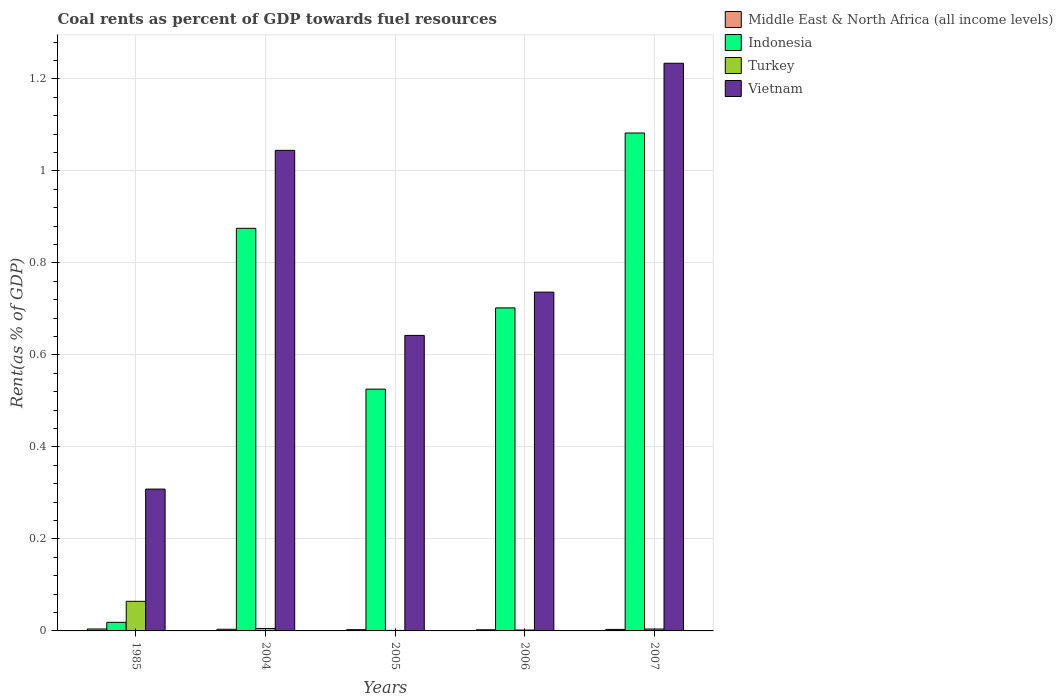How many groups of bars are there?
Keep it short and to the point. 5. Are the number of bars per tick equal to the number of legend labels?
Make the answer very short. Yes. What is the label of the 4th group of bars from the left?
Offer a very short reply. 2006. What is the coal rent in Indonesia in 2004?
Provide a succinct answer. 0.88. Across all years, what is the maximum coal rent in Vietnam?
Ensure brevity in your answer.  1.23. Across all years, what is the minimum coal rent in Middle East & North Africa (all income levels)?
Your answer should be very brief. 0. What is the total coal rent in Turkey in the graph?
Provide a succinct answer. 0.08. What is the difference between the coal rent in Indonesia in 2004 and that in 2006?
Offer a very short reply. 0.17. What is the difference between the coal rent in Vietnam in 2007 and the coal rent in Indonesia in 2004?
Your response must be concise. 0.36. What is the average coal rent in Vietnam per year?
Keep it short and to the point. 0.79. In the year 2006, what is the difference between the coal rent in Indonesia and coal rent in Turkey?
Ensure brevity in your answer.  0.7. In how many years, is the coal rent in Indonesia greater than 0.48000000000000004 %?
Make the answer very short. 4. What is the ratio of the coal rent in Middle East & North Africa (all income levels) in 1985 to that in 2007?
Ensure brevity in your answer.  1.29. Is the coal rent in Middle East & North Africa (all income levels) in 2006 less than that in 2007?
Make the answer very short. Yes. What is the difference between the highest and the second highest coal rent in Turkey?
Make the answer very short. 0.06. What is the difference between the highest and the lowest coal rent in Indonesia?
Offer a very short reply. 1.06. Is it the case that in every year, the sum of the coal rent in Middle East & North Africa (all income levels) and coal rent in Vietnam is greater than the sum of coal rent in Indonesia and coal rent in Turkey?
Give a very brief answer. Yes. What does the 4th bar from the left in 2004 represents?
Keep it short and to the point. Vietnam. What does the 1st bar from the right in 2007 represents?
Offer a terse response. Vietnam. Is it the case that in every year, the sum of the coal rent in Vietnam and coal rent in Turkey is greater than the coal rent in Indonesia?
Offer a terse response. Yes. What is the difference between two consecutive major ticks on the Y-axis?
Offer a very short reply. 0.2. Are the values on the major ticks of Y-axis written in scientific E-notation?
Offer a terse response. No. Where does the legend appear in the graph?
Ensure brevity in your answer.  Top right. How many legend labels are there?
Offer a very short reply. 4. How are the legend labels stacked?
Provide a short and direct response. Vertical. What is the title of the graph?
Provide a succinct answer. Coal rents as percent of GDP towards fuel resources. What is the label or title of the Y-axis?
Offer a very short reply. Rent(as % of GDP). What is the Rent(as % of GDP) of Middle East & North Africa (all income levels) in 1985?
Your answer should be very brief. 0. What is the Rent(as % of GDP) in Indonesia in 1985?
Make the answer very short. 0.02. What is the Rent(as % of GDP) of Turkey in 1985?
Offer a very short reply. 0.06. What is the Rent(as % of GDP) in Vietnam in 1985?
Keep it short and to the point. 0.31. What is the Rent(as % of GDP) in Middle East & North Africa (all income levels) in 2004?
Your response must be concise. 0. What is the Rent(as % of GDP) in Indonesia in 2004?
Your answer should be very brief. 0.88. What is the Rent(as % of GDP) in Turkey in 2004?
Provide a short and direct response. 0.01. What is the Rent(as % of GDP) of Vietnam in 2004?
Your answer should be very brief. 1.04. What is the Rent(as % of GDP) in Middle East & North Africa (all income levels) in 2005?
Provide a succinct answer. 0. What is the Rent(as % of GDP) in Indonesia in 2005?
Your response must be concise. 0.53. What is the Rent(as % of GDP) of Turkey in 2005?
Make the answer very short. 0. What is the Rent(as % of GDP) in Vietnam in 2005?
Give a very brief answer. 0.64. What is the Rent(as % of GDP) in Middle East & North Africa (all income levels) in 2006?
Offer a terse response. 0. What is the Rent(as % of GDP) in Indonesia in 2006?
Keep it short and to the point. 0.7. What is the Rent(as % of GDP) of Turkey in 2006?
Your response must be concise. 0. What is the Rent(as % of GDP) of Vietnam in 2006?
Make the answer very short. 0.74. What is the Rent(as % of GDP) in Middle East & North Africa (all income levels) in 2007?
Provide a succinct answer. 0. What is the Rent(as % of GDP) of Indonesia in 2007?
Your answer should be compact. 1.08. What is the Rent(as % of GDP) of Turkey in 2007?
Provide a succinct answer. 0. What is the Rent(as % of GDP) in Vietnam in 2007?
Keep it short and to the point. 1.23. Across all years, what is the maximum Rent(as % of GDP) in Middle East & North Africa (all income levels)?
Provide a short and direct response. 0. Across all years, what is the maximum Rent(as % of GDP) in Indonesia?
Make the answer very short. 1.08. Across all years, what is the maximum Rent(as % of GDP) of Turkey?
Your answer should be very brief. 0.06. Across all years, what is the maximum Rent(as % of GDP) of Vietnam?
Offer a very short reply. 1.23. Across all years, what is the minimum Rent(as % of GDP) in Middle East & North Africa (all income levels)?
Offer a terse response. 0. Across all years, what is the minimum Rent(as % of GDP) in Indonesia?
Give a very brief answer. 0.02. Across all years, what is the minimum Rent(as % of GDP) in Turkey?
Keep it short and to the point. 0. Across all years, what is the minimum Rent(as % of GDP) in Vietnam?
Your answer should be compact. 0.31. What is the total Rent(as % of GDP) of Middle East & North Africa (all income levels) in the graph?
Give a very brief answer. 0.02. What is the total Rent(as % of GDP) in Indonesia in the graph?
Keep it short and to the point. 3.2. What is the total Rent(as % of GDP) in Turkey in the graph?
Give a very brief answer. 0.08. What is the total Rent(as % of GDP) in Vietnam in the graph?
Offer a very short reply. 3.97. What is the difference between the Rent(as % of GDP) in Middle East & North Africa (all income levels) in 1985 and that in 2004?
Ensure brevity in your answer.  0. What is the difference between the Rent(as % of GDP) in Indonesia in 1985 and that in 2004?
Make the answer very short. -0.86. What is the difference between the Rent(as % of GDP) of Turkey in 1985 and that in 2004?
Your answer should be compact. 0.06. What is the difference between the Rent(as % of GDP) of Vietnam in 1985 and that in 2004?
Offer a terse response. -0.74. What is the difference between the Rent(as % of GDP) of Middle East & North Africa (all income levels) in 1985 and that in 2005?
Provide a short and direct response. 0. What is the difference between the Rent(as % of GDP) in Indonesia in 1985 and that in 2005?
Offer a terse response. -0.51. What is the difference between the Rent(as % of GDP) in Turkey in 1985 and that in 2005?
Offer a very short reply. 0.06. What is the difference between the Rent(as % of GDP) of Vietnam in 1985 and that in 2005?
Give a very brief answer. -0.33. What is the difference between the Rent(as % of GDP) in Middle East & North Africa (all income levels) in 1985 and that in 2006?
Your answer should be very brief. 0. What is the difference between the Rent(as % of GDP) of Indonesia in 1985 and that in 2006?
Your answer should be very brief. -0.68. What is the difference between the Rent(as % of GDP) in Turkey in 1985 and that in 2006?
Make the answer very short. 0.06. What is the difference between the Rent(as % of GDP) of Vietnam in 1985 and that in 2006?
Ensure brevity in your answer.  -0.43. What is the difference between the Rent(as % of GDP) in Indonesia in 1985 and that in 2007?
Your response must be concise. -1.06. What is the difference between the Rent(as % of GDP) in Turkey in 1985 and that in 2007?
Make the answer very short. 0.06. What is the difference between the Rent(as % of GDP) in Vietnam in 1985 and that in 2007?
Offer a very short reply. -0.93. What is the difference between the Rent(as % of GDP) of Middle East & North Africa (all income levels) in 2004 and that in 2005?
Your answer should be compact. 0. What is the difference between the Rent(as % of GDP) of Indonesia in 2004 and that in 2005?
Keep it short and to the point. 0.35. What is the difference between the Rent(as % of GDP) in Turkey in 2004 and that in 2005?
Provide a short and direct response. 0. What is the difference between the Rent(as % of GDP) of Vietnam in 2004 and that in 2005?
Offer a terse response. 0.4. What is the difference between the Rent(as % of GDP) of Middle East & North Africa (all income levels) in 2004 and that in 2006?
Your answer should be compact. 0. What is the difference between the Rent(as % of GDP) in Indonesia in 2004 and that in 2006?
Provide a succinct answer. 0.17. What is the difference between the Rent(as % of GDP) of Turkey in 2004 and that in 2006?
Your answer should be very brief. 0. What is the difference between the Rent(as % of GDP) of Vietnam in 2004 and that in 2006?
Your response must be concise. 0.31. What is the difference between the Rent(as % of GDP) in Middle East & North Africa (all income levels) in 2004 and that in 2007?
Provide a succinct answer. 0. What is the difference between the Rent(as % of GDP) in Indonesia in 2004 and that in 2007?
Your response must be concise. -0.21. What is the difference between the Rent(as % of GDP) of Turkey in 2004 and that in 2007?
Offer a terse response. 0. What is the difference between the Rent(as % of GDP) in Vietnam in 2004 and that in 2007?
Give a very brief answer. -0.19. What is the difference between the Rent(as % of GDP) in Middle East & North Africa (all income levels) in 2005 and that in 2006?
Provide a succinct answer. 0. What is the difference between the Rent(as % of GDP) in Indonesia in 2005 and that in 2006?
Keep it short and to the point. -0.18. What is the difference between the Rent(as % of GDP) in Turkey in 2005 and that in 2006?
Ensure brevity in your answer.  -0. What is the difference between the Rent(as % of GDP) in Vietnam in 2005 and that in 2006?
Provide a succinct answer. -0.09. What is the difference between the Rent(as % of GDP) in Middle East & North Africa (all income levels) in 2005 and that in 2007?
Keep it short and to the point. -0. What is the difference between the Rent(as % of GDP) in Indonesia in 2005 and that in 2007?
Offer a terse response. -0.56. What is the difference between the Rent(as % of GDP) of Turkey in 2005 and that in 2007?
Your answer should be compact. -0. What is the difference between the Rent(as % of GDP) in Vietnam in 2005 and that in 2007?
Your response must be concise. -0.59. What is the difference between the Rent(as % of GDP) in Middle East & North Africa (all income levels) in 2006 and that in 2007?
Your answer should be very brief. -0. What is the difference between the Rent(as % of GDP) of Indonesia in 2006 and that in 2007?
Provide a succinct answer. -0.38. What is the difference between the Rent(as % of GDP) of Turkey in 2006 and that in 2007?
Your answer should be compact. -0. What is the difference between the Rent(as % of GDP) of Vietnam in 2006 and that in 2007?
Your response must be concise. -0.5. What is the difference between the Rent(as % of GDP) of Middle East & North Africa (all income levels) in 1985 and the Rent(as % of GDP) of Indonesia in 2004?
Your answer should be very brief. -0.87. What is the difference between the Rent(as % of GDP) in Middle East & North Africa (all income levels) in 1985 and the Rent(as % of GDP) in Turkey in 2004?
Ensure brevity in your answer.  -0. What is the difference between the Rent(as % of GDP) of Middle East & North Africa (all income levels) in 1985 and the Rent(as % of GDP) of Vietnam in 2004?
Provide a succinct answer. -1.04. What is the difference between the Rent(as % of GDP) of Indonesia in 1985 and the Rent(as % of GDP) of Turkey in 2004?
Keep it short and to the point. 0.01. What is the difference between the Rent(as % of GDP) of Indonesia in 1985 and the Rent(as % of GDP) of Vietnam in 2004?
Offer a very short reply. -1.03. What is the difference between the Rent(as % of GDP) in Turkey in 1985 and the Rent(as % of GDP) in Vietnam in 2004?
Provide a short and direct response. -0.98. What is the difference between the Rent(as % of GDP) of Middle East & North Africa (all income levels) in 1985 and the Rent(as % of GDP) of Indonesia in 2005?
Offer a terse response. -0.52. What is the difference between the Rent(as % of GDP) of Middle East & North Africa (all income levels) in 1985 and the Rent(as % of GDP) of Turkey in 2005?
Keep it short and to the point. 0. What is the difference between the Rent(as % of GDP) in Middle East & North Africa (all income levels) in 1985 and the Rent(as % of GDP) in Vietnam in 2005?
Provide a succinct answer. -0.64. What is the difference between the Rent(as % of GDP) of Indonesia in 1985 and the Rent(as % of GDP) of Turkey in 2005?
Your answer should be very brief. 0.02. What is the difference between the Rent(as % of GDP) in Indonesia in 1985 and the Rent(as % of GDP) in Vietnam in 2005?
Provide a succinct answer. -0.62. What is the difference between the Rent(as % of GDP) of Turkey in 1985 and the Rent(as % of GDP) of Vietnam in 2005?
Your answer should be very brief. -0.58. What is the difference between the Rent(as % of GDP) of Middle East & North Africa (all income levels) in 1985 and the Rent(as % of GDP) of Indonesia in 2006?
Provide a succinct answer. -0.7. What is the difference between the Rent(as % of GDP) in Middle East & North Africa (all income levels) in 1985 and the Rent(as % of GDP) in Turkey in 2006?
Provide a short and direct response. 0. What is the difference between the Rent(as % of GDP) in Middle East & North Africa (all income levels) in 1985 and the Rent(as % of GDP) in Vietnam in 2006?
Your answer should be compact. -0.73. What is the difference between the Rent(as % of GDP) of Indonesia in 1985 and the Rent(as % of GDP) of Turkey in 2006?
Keep it short and to the point. 0.02. What is the difference between the Rent(as % of GDP) in Indonesia in 1985 and the Rent(as % of GDP) in Vietnam in 2006?
Offer a terse response. -0.72. What is the difference between the Rent(as % of GDP) in Turkey in 1985 and the Rent(as % of GDP) in Vietnam in 2006?
Your answer should be compact. -0.67. What is the difference between the Rent(as % of GDP) in Middle East & North Africa (all income levels) in 1985 and the Rent(as % of GDP) in Indonesia in 2007?
Provide a short and direct response. -1.08. What is the difference between the Rent(as % of GDP) of Middle East & North Africa (all income levels) in 1985 and the Rent(as % of GDP) of Turkey in 2007?
Your response must be concise. 0. What is the difference between the Rent(as % of GDP) of Middle East & North Africa (all income levels) in 1985 and the Rent(as % of GDP) of Vietnam in 2007?
Keep it short and to the point. -1.23. What is the difference between the Rent(as % of GDP) of Indonesia in 1985 and the Rent(as % of GDP) of Turkey in 2007?
Offer a very short reply. 0.01. What is the difference between the Rent(as % of GDP) in Indonesia in 1985 and the Rent(as % of GDP) in Vietnam in 2007?
Offer a terse response. -1.22. What is the difference between the Rent(as % of GDP) in Turkey in 1985 and the Rent(as % of GDP) in Vietnam in 2007?
Offer a very short reply. -1.17. What is the difference between the Rent(as % of GDP) in Middle East & North Africa (all income levels) in 2004 and the Rent(as % of GDP) in Indonesia in 2005?
Ensure brevity in your answer.  -0.52. What is the difference between the Rent(as % of GDP) in Middle East & North Africa (all income levels) in 2004 and the Rent(as % of GDP) in Turkey in 2005?
Your answer should be compact. 0. What is the difference between the Rent(as % of GDP) in Middle East & North Africa (all income levels) in 2004 and the Rent(as % of GDP) in Vietnam in 2005?
Ensure brevity in your answer.  -0.64. What is the difference between the Rent(as % of GDP) in Indonesia in 2004 and the Rent(as % of GDP) in Turkey in 2005?
Make the answer very short. 0.87. What is the difference between the Rent(as % of GDP) of Indonesia in 2004 and the Rent(as % of GDP) of Vietnam in 2005?
Provide a short and direct response. 0.23. What is the difference between the Rent(as % of GDP) of Turkey in 2004 and the Rent(as % of GDP) of Vietnam in 2005?
Make the answer very short. -0.64. What is the difference between the Rent(as % of GDP) of Middle East & North Africa (all income levels) in 2004 and the Rent(as % of GDP) of Indonesia in 2006?
Provide a short and direct response. -0.7. What is the difference between the Rent(as % of GDP) of Middle East & North Africa (all income levels) in 2004 and the Rent(as % of GDP) of Turkey in 2006?
Your response must be concise. 0. What is the difference between the Rent(as % of GDP) of Middle East & North Africa (all income levels) in 2004 and the Rent(as % of GDP) of Vietnam in 2006?
Give a very brief answer. -0.73. What is the difference between the Rent(as % of GDP) in Indonesia in 2004 and the Rent(as % of GDP) in Turkey in 2006?
Provide a short and direct response. 0.87. What is the difference between the Rent(as % of GDP) of Indonesia in 2004 and the Rent(as % of GDP) of Vietnam in 2006?
Give a very brief answer. 0.14. What is the difference between the Rent(as % of GDP) in Turkey in 2004 and the Rent(as % of GDP) in Vietnam in 2006?
Make the answer very short. -0.73. What is the difference between the Rent(as % of GDP) in Middle East & North Africa (all income levels) in 2004 and the Rent(as % of GDP) in Indonesia in 2007?
Provide a succinct answer. -1.08. What is the difference between the Rent(as % of GDP) of Middle East & North Africa (all income levels) in 2004 and the Rent(as % of GDP) of Turkey in 2007?
Provide a short and direct response. -0. What is the difference between the Rent(as % of GDP) in Middle East & North Africa (all income levels) in 2004 and the Rent(as % of GDP) in Vietnam in 2007?
Your answer should be compact. -1.23. What is the difference between the Rent(as % of GDP) of Indonesia in 2004 and the Rent(as % of GDP) of Turkey in 2007?
Your answer should be compact. 0.87. What is the difference between the Rent(as % of GDP) of Indonesia in 2004 and the Rent(as % of GDP) of Vietnam in 2007?
Keep it short and to the point. -0.36. What is the difference between the Rent(as % of GDP) of Turkey in 2004 and the Rent(as % of GDP) of Vietnam in 2007?
Your answer should be very brief. -1.23. What is the difference between the Rent(as % of GDP) in Middle East & North Africa (all income levels) in 2005 and the Rent(as % of GDP) in Indonesia in 2006?
Provide a succinct answer. -0.7. What is the difference between the Rent(as % of GDP) in Middle East & North Africa (all income levels) in 2005 and the Rent(as % of GDP) in Turkey in 2006?
Provide a succinct answer. 0. What is the difference between the Rent(as % of GDP) of Middle East & North Africa (all income levels) in 2005 and the Rent(as % of GDP) of Vietnam in 2006?
Your answer should be compact. -0.73. What is the difference between the Rent(as % of GDP) in Indonesia in 2005 and the Rent(as % of GDP) in Turkey in 2006?
Your response must be concise. 0.52. What is the difference between the Rent(as % of GDP) in Indonesia in 2005 and the Rent(as % of GDP) in Vietnam in 2006?
Make the answer very short. -0.21. What is the difference between the Rent(as % of GDP) in Turkey in 2005 and the Rent(as % of GDP) in Vietnam in 2006?
Offer a terse response. -0.74. What is the difference between the Rent(as % of GDP) in Middle East & North Africa (all income levels) in 2005 and the Rent(as % of GDP) in Indonesia in 2007?
Offer a very short reply. -1.08. What is the difference between the Rent(as % of GDP) of Middle East & North Africa (all income levels) in 2005 and the Rent(as % of GDP) of Turkey in 2007?
Your answer should be very brief. -0. What is the difference between the Rent(as % of GDP) in Middle East & North Africa (all income levels) in 2005 and the Rent(as % of GDP) in Vietnam in 2007?
Your response must be concise. -1.23. What is the difference between the Rent(as % of GDP) in Indonesia in 2005 and the Rent(as % of GDP) in Turkey in 2007?
Keep it short and to the point. 0.52. What is the difference between the Rent(as % of GDP) of Indonesia in 2005 and the Rent(as % of GDP) of Vietnam in 2007?
Provide a succinct answer. -0.71. What is the difference between the Rent(as % of GDP) in Turkey in 2005 and the Rent(as % of GDP) in Vietnam in 2007?
Provide a succinct answer. -1.23. What is the difference between the Rent(as % of GDP) of Middle East & North Africa (all income levels) in 2006 and the Rent(as % of GDP) of Indonesia in 2007?
Give a very brief answer. -1.08. What is the difference between the Rent(as % of GDP) in Middle East & North Africa (all income levels) in 2006 and the Rent(as % of GDP) in Turkey in 2007?
Keep it short and to the point. -0. What is the difference between the Rent(as % of GDP) of Middle East & North Africa (all income levels) in 2006 and the Rent(as % of GDP) of Vietnam in 2007?
Provide a short and direct response. -1.23. What is the difference between the Rent(as % of GDP) in Indonesia in 2006 and the Rent(as % of GDP) in Turkey in 2007?
Give a very brief answer. 0.7. What is the difference between the Rent(as % of GDP) in Indonesia in 2006 and the Rent(as % of GDP) in Vietnam in 2007?
Provide a succinct answer. -0.53. What is the difference between the Rent(as % of GDP) of Turkey in 2006 and the Rent(as % of GDP) of Vietnam in 2007?
Your response must be concise. -1.23. What is the average Rent(as % of GDP) in Middle East & North Africa (all income levels) per year?
Your answer should be very brief. 0. What is the average Rent(as % of GDP) in Indonesia per year?
Provide a succinct answer. 0.64. What is the average Rent(as % of GDP) in Turkey per year?
Provide a short and direct response. 0.02. What is the average Rent(as % of GDP) in Vietnam per year?
Provide a short and direct response. 0.79. In the year 1985, what is the difference between the Rent(as % of GDP) of Middle East & North Africa (all income levels) and Rent(as % of GDP) of Indonesia?
Your response must be concise. -0.01. In the year 1985, what is the difference between the Rent(as % of GDP) of Middle East & North Africa (all income levels) and Rent(as % of GDP) of Turkey?
Provide a short and direct response. -0.06. In the year 1985, what is the difference between the Rent(as % of GDP) in Middle East & North Africa (all income levels) and Rent(as % of GDP) in Vietnam?
Your answer should be very brief. -0.3. In the year 1985, what is the difference between the Rent(as % of GDP) in Indonesia and Rent(as % of GDP) in Turkey?
Provide a succinct answer. -0.05. In the year 1985, what is the difference between the Rent(as % of GDP) in Indonesia and Rent(as % of GDP) in Vietnam?
Ensure brevity in your answer.  -0.29. In the year 1985, what is the difference between the Rent(as % of GDP) in Turkey and Rent(as % of GDP) in Vietnam?
Give a very brief answer. -0.24. In the year 2004, what is the difference between the Rent(as % of GDP) in Middle East & North Africa (all income levels) and Rent(as % of GDP) in Indonesia?
Provide a succinct answer. -0.87. In the year 2004, what is the difference between the Rent(as % of GDP) of Middle East & North Africa (all income levels) and Rent(as % of GDP) of Turkey?
Keep it short and to the point. -0. In the year 2004, what is the difference between the Rent(as % of GDP) of Middle East & North Africa (all income levels) and Rent(as % of GDP) of Vietnam?
Ensure brevity in your answer.  -1.04. In the year 2004, what is the difference between the Rent(as % of GDP) of Indonesia and Rent(as % of GDP) of Turkey?
Provide a succinct answer. 0.87. In the year 2004, what is the difference between the Rent(as % of GDP) of Indonesia and Rent(as % of GDP) of Vietnam?
Provide a short and direct response. -0.17. In the year 2004, what is the difference between the Rent(as % of GDP) in Turkey and Rent(as % of GDP) in Vietnam?
Provide a succinct answer. -1.04. In the year 2005, what is the difference between the Rent(as % of GDP) in Middle East & North Africa (all income levels) and Rent(as % of GDP) in Indonesia?
Make the answer very short. -0.52. In the year 2005, what is the difference between the Rent(as % of GDP) of Middle East & North Africa (all income levels) and Rent(as % of GDP) of Turkey?
Your answer should be compact. 0. In the year 2005, what is the difference between the Rent(as % of GDP) in Middle East & North Africa (all income levels) and Rent(as % of GDP) in Vietnam?
Your answer should be very brief. -0.64. In the year 2005, what is the difference between the Rent(as % of GDP) of Indonesia and Rent(as % of GDP) of Turkey?
Offer a very short reply. 0.52. In the year 2005, what is the difference between the Rent(as % of GDP) in Indonesia and Rent(as % of GDP) in Vietnam?
Offer a very short reply. -0.12. In the year 2005, what is the difference between the Rent(as % of GDP) of Turkey and Rent(as % of GDP) of Vietnam?
Your answer should be very brief. -0.64. In the year 2006, what is the difference between the Rent(as % of GDP) of Middle East & North Africa (all income levels) and Rent(as % of GDP) of Indonesia?
Give a very brief answer. -0.7. In the year 2006, what is the difference between the Rent(as % of GDP) in Middle East & North Africa (all income levels) and Rent(as % of GDP) in Turkey?
Provide a short and direct response. 0. In the year 2006, what is the difference between the Rent(as % of GDP) of Middle East & North Africa (all income levels) and Rent(as % of GDP) of Vietnam?
Offer a terse response. -0.73. In the year 2006, what is the difference between the Rent(as % of GDP) in Indonesia and Rent(as % of GDP) in Turkey?
Provide a short and direct response. 0.7. In the year 2006, what is the difference between the Rent(as % of GDP) in Indonesia and Rent(as % of GDP) in Vietnam?
Offer a terse response. -0.03. In the year 2006, what is the difference between the Rent(as % of GDP) in Turkey and Rent(as % of GDP) in Vietnam?
Your answer should be compact. -0.73. In the year 2007, what is the difference between the Rent(as % of GDP) in Middle East & North Africa (all income levels) and Rent(as % of GDP) in Indonesia?
Give a very brief answer. -1.08. In the year 2007, what is the difference between the Rent(as % of GDP) in Middle East & North Africa (all income levels) and Rent(as % of GDP) in Turkey?
Ensure brevity in your answer.  -0. In the year 2007, what is the difference between the Rent(as % of GDP) of Middle East & North Africa (all income levels) and Rent(as % of GDP) of Vietnam?
Keep it short and to the point. -1.23. In the year 2007, what is the difference between the Rent(as % of GDP) of Indonesia and Rent(as % of GDP) of Turkey?
Make the answer very short. 1.08. In the year 2007, what is the difference between the Rent(as % of GDP) of Indonesia and Rent(as % of GDP) of Vietnam?
Keep it short and to the point. -0.15. In the year 2007, what is the difference between the Rent(as % of GDP) in Turkey and Rent(as % of GDP) in Vietnam?
Give a very brief answer. -1.23. What is the ratio of the Rent(as % of GDP) in Middle East & North Africa (all income levels) in 1985 to that in 2004?
Make the answer very short. 1.17. What is the ratio of the Rent(as % of GDP) of Indonesia in 1985 to that in 2004?
Provide a succinct answer. 0.02. What is the ratio of the Rent(as % of GDP) of Turkey in 1985 to that in 2004?
Your answer should be very brief. 12.07. What is the ratio of the Rent(as % of GDP) in Vietnam in 1985 to that in 2004?
Your answer should be compact. 0.3. What is the ratio of the Rent(as % of GDP) of Middle East & North Africa (all income levels) in 1985 to that in 2005?
Give a very brief answer. 1.55. What is the ratio of the Rent(as % of GDP) of Indonesia in 1985 to that in 2005?
Offer a terse response. 0.04. What is the ratio of the Rent(as % of GDP) in Turkey in 1985 to that in 2005?
Provide a succinct answer. 55.91. What is the ratio of the Rent(as % of GDP) of Vietnam in 1985 to that in 2005?
Ensure brevity in your answer.  0.48. What is the ratio of the Rent(as % of GDP) in Middle East & North Africa (all income levels) in 1985 to that in 2006?
Your answer should be compact. 1.68. What is the ratio of the Rent(as % of GDP) in Indonesia in 1985 to that in 2006?
Ensure brevity in your answer.  0.03. What is the ratio of the Rent(as % of GDP) of Turkey in 1985 to that in 2006?
Ensure brevity in your answer.  33.66. What is the ratio of the Rent(as % of GDP) in Vietnam in 1985 to that in 2006?
Give a very brief answer. 0.42. What is the ratio of the Rent(as % of GDP) of Middle East & North Africa (all income levels) in 1985 to that in 2007?
Offer a very short reply. 1.29. What is the ratio of the Rent(as % of GDP) in Indonesia in 1985 to that in 2007?
Offer a very short reply. 0.02. What is the ratio of the Rent(as % of GDP) of Turkey in 1985 to that in 2007?
Your answer should be very brief. 15.64. What is the ratio of the Rent(as % of GDP) in Vietnam in 1985 to that in 2007?
Your answer should be compact. 0.25. What is the ratio of the Rent(as % of GDP) in Middle East & North Africa (all income levels) in 2004 to that in 2005?
Offer a terse response. 1.32. What is the ratio of the Rent(as % of GDP) of Indonesia in 2004 to that in 2005?
Provide a succinct answer. 1.67. What is the ratio of the Rent(as % of GDP) in Turkey in 2004 to that in 2005?
Your answer should be compact. 4.63. What is the ratio of the Rent(as % of GDP) of Vietnam in 2004 to that in 2005?
Your response must be concise. 1.63. What is the ratio of the Rent(as % of GDP) in Middle East & North Africa (all income levels) in 2004 to that in 2006?
Keep it short and to the point. 1.43. What is the ratio of the Rent(as % of GDP) in Indonesia in 2004 to that in 2006?
Ensure brevity in your answer.  1.25. What is the ratio of the Rent(as % of GDP) in Turkey in 2004 to that in 2006?
Keep it short and to the point. 2.79. What is the ratio of the Rent(as % of GDP) in Vietnam in 2004 to that in 2006?
Your answer should be compact. 1.42. What is the ratio of the Rent(as % of GDP) of Middle East & North Africa (all income levels) in 2004 to that in 2007?
Provide a short and direct response. 1.1. What is the ratio of the Rent(as % of GDP) in Indonesia in 2004 to that in 2007?
Give a very brief answer. 0.81. What is the ratio of the Rent(as % of GDP) in Turkey in 2004 to that in 2007?
Provide a short and direct response. 1.3. What is the ratio of the Rent(as % of GDP) in Vietnam in 2004 to that in 2007?
Give a very brief answer. 0.85. What is the ratio of the Rent(as % of GDP) in Middle East & North Africa (all income levels) in 2005 to that in 2006?
Keep it short and to the point. 1.08. What is the ratio of the Rent(as % of GDP) in Indonesia in 2005 to that in 2006?
Ensure brevity in your answer.  0.75. What is the ratio of the Rent(as % of GDP) in Turkey in 2005 to that in 2006?
Ensure brevity in your answer.  0.6. What is the ratio of the Rent(as % of GDP) of Vietnam in 2005 to that in 2006?
Offer a very short reply. 0.87. What is the ratio of the Rent(as % of GDP) in Middle East & North Africa (all income levels) in 2005 to that in 2007?
Provide a short and direct response. 0.84. What is the ratio of the Rent(as % of GDP) in Indonesia in 2005 to that in 2007?
Make the answer very short. 0.49. What is the ratio of the Rent(as % of GDP) of Turkey in 2005 to that in 2007?
Keep it short and to the point. 0.28. What is the ratio of the Rent(as % of GDP) of Vietnam in 2005 to that in 2007?
Ensure brevity in your answer.  0.52. What is the ratio of the Rent(as % of GDP) of Middle East & North Africa (all income levels) in 2006 to that in 2007?
Your answer should be very brief. 0.77. What is the ratio of the Rent(as % of GDP) of Indonesia in 2006 to that in 2007?
Your answer should be compact. 0.65. What is the ratio of the Rent(as % of GDP) of Turkey in 2006 to that in 2007?
Keep it short and to the point. 0.46. What is the ratio of the Rent(as % of GDP) of Vietnam in 2006 to that in 2007?
Provide a short and direct response. 0.6. What is the difference between the highest and the second highest Rent(as % of GDP) of Middle East & North Africa (all income levels)?
Provide a succinct answer. 0. What is the difference between the highest and the second highest Rent(as % of GDP) in Indonesia?
Keep it short and to the point. 0.21. What is the difference between the highest and the second highest Rent(as % of GDP) of Turkey?
Your answer should be very brief. 0.06. What is the difference between the highest and the second highest Rent(as % of GDP) in Vietnam?
Give a very brief answer. 0.19. What is the difference between the highest and the lowest Rent(as % of GDP) of Middle East & North Africa (all income levels)?
Your response must be concise. 0. What is the difference between the highest and the lowest Rent(as % of GDP) in Indonesia?
Your answer should be very brief. 1.06. What is the difference between the highest and the lowest Rent(as % of GDP) of Turkey?
Offer a terse response. 0.06. What is the difference between the highest and the lowest Rent(as % of GDP) in Vietnam?
Ensure brevity in your answer.  0.93. 